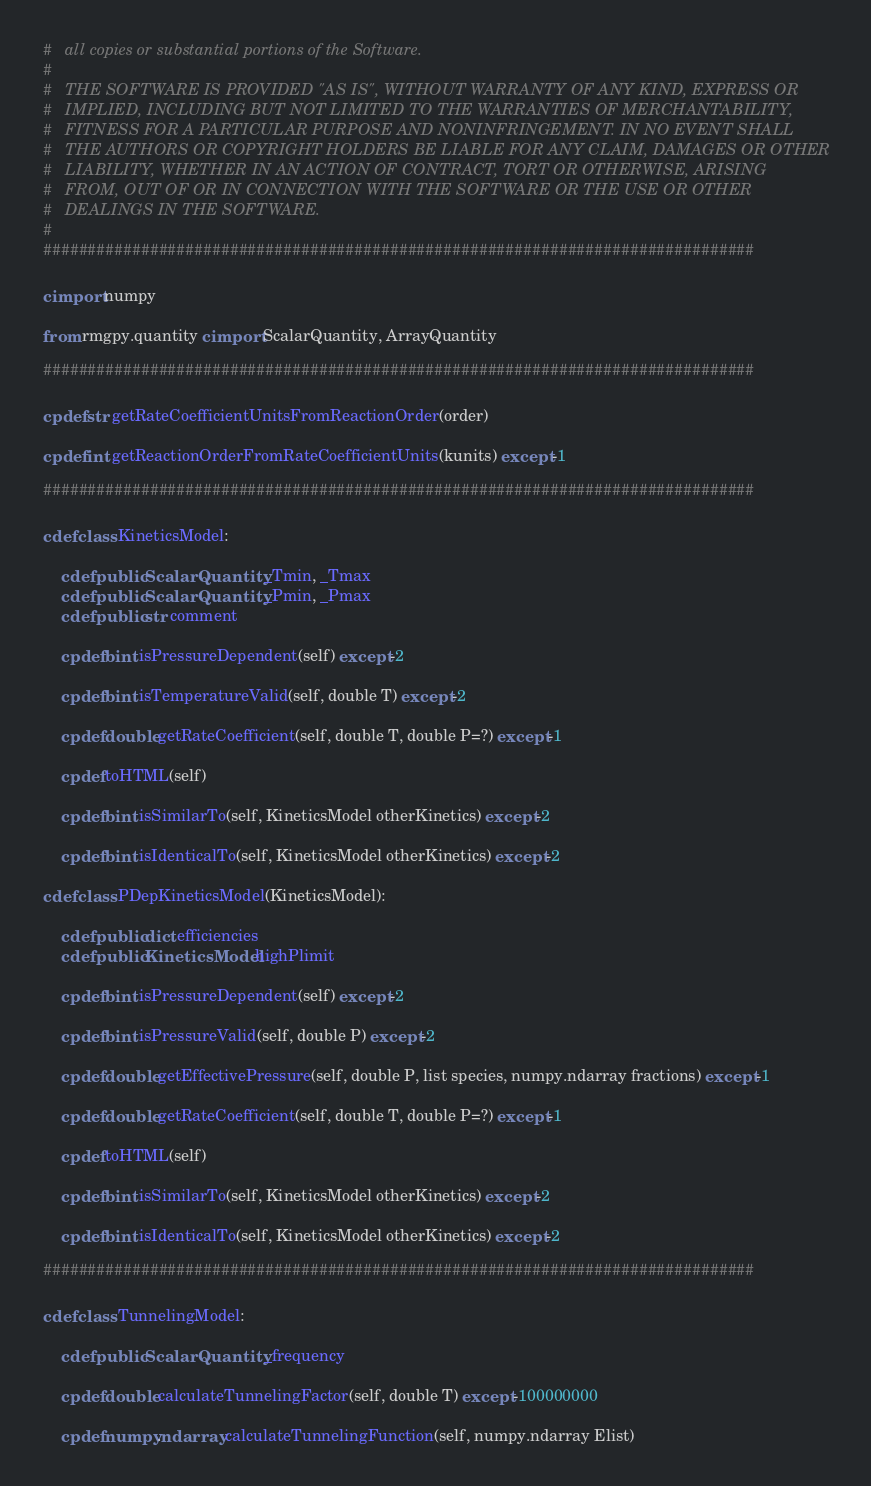<code> <loc_0><loc_0><loc_500><loc_500><_Cython_>#   all copies or substantial portions of the Software.
#
#   THE SOFTWARE IS PROVIDED "AS IS", WITHOUT WARRANTY OF ANY KIND, EXPRESS OR
#   IMPLIED, INCLUDING BUT NOT LIMITED TO THE WARRANTIES OF MERCHANTABILITY,
#   FITNESS FOR A PARTICULAR PURPOSE AND NONINFRINGEMENT. IN NO EVENT SHALL
#   THE AUTHORS OR COPYRIGHT HOLDERS BE LIABLE FOR ANY CLAIM, DAMAGES OR OTHER
#   LIABILITY, WHETHER IN AN ACTION OF CONTRACT, TORT OR OTHERWISE, ARISING
#   FROM, OUT OF OR IN CONNECTION WITH THE SOFTWARE OR THE USE OR OTHER
#   DEALINGS IN THE SOFTWARE.
#
################################################################################

cimport numpy

from rmgpy.quantity cimport ScalarQuantity, ArrayQuantity

################################################################################

cpdef str getRateCoefficientUnitsFromReactionOrder(order)

cpdef int getReactionOrderFromRateCoefficientUnits(kunits) except -1

################################################################################

cdef class KineticsModel:
    
    cdef public ScalarQuantity _Tmin, _Tmax
    cdef public ScalarQuantity _Pmin, _Pmax
    cdef public str comment
    
    cpdef bint isPressureDependent(self) except -2
    
    cpdef bint isTemperatureValid(self, double T) except -2

    cpdef double getRateCoefficient(self, double T, double P=?) except -1
    
    cpdef toHTML(self)

    cpdef bint isSimilarTo(self, KineticsModel otherKinetics) except -2

    cpdef bint isIdenticalTo(self, KineticsModel otherKinetics) except -2

cdef class PDepKineticsModel(KineticsModel):
    
    cdef public dict efficiencies
    cdef public KineticsModel highPlimit
    
    cpdef bint isPressureDependent(self) except -2
    
    cpdef bint isPressureValid(self, double P) except -2

    cpdef double getEffectivePressure(self, double P, list species, numpy.ndarray fractions) except -1

    cpdef double getRateCoefficient(self, double T, double P=?) except -1

    cpdef toHTML(self)

    cpdef bint isSimilarTo(self, KineticsModel otherKinetics) except -2

    cpdef bint isIdenticalTo(self, KineticsModel otherKinetics) except -2

################################################################################

cdef class TunnelingModel:

    cdef public ScalarQuantity _frequency

    cpdef double calculateTunnelingFactor(self, double T) except -100000000

    cpdef numpy.ndarray calculateTunnelingFunction(self, numpy.ndarray Elist)
</code> 